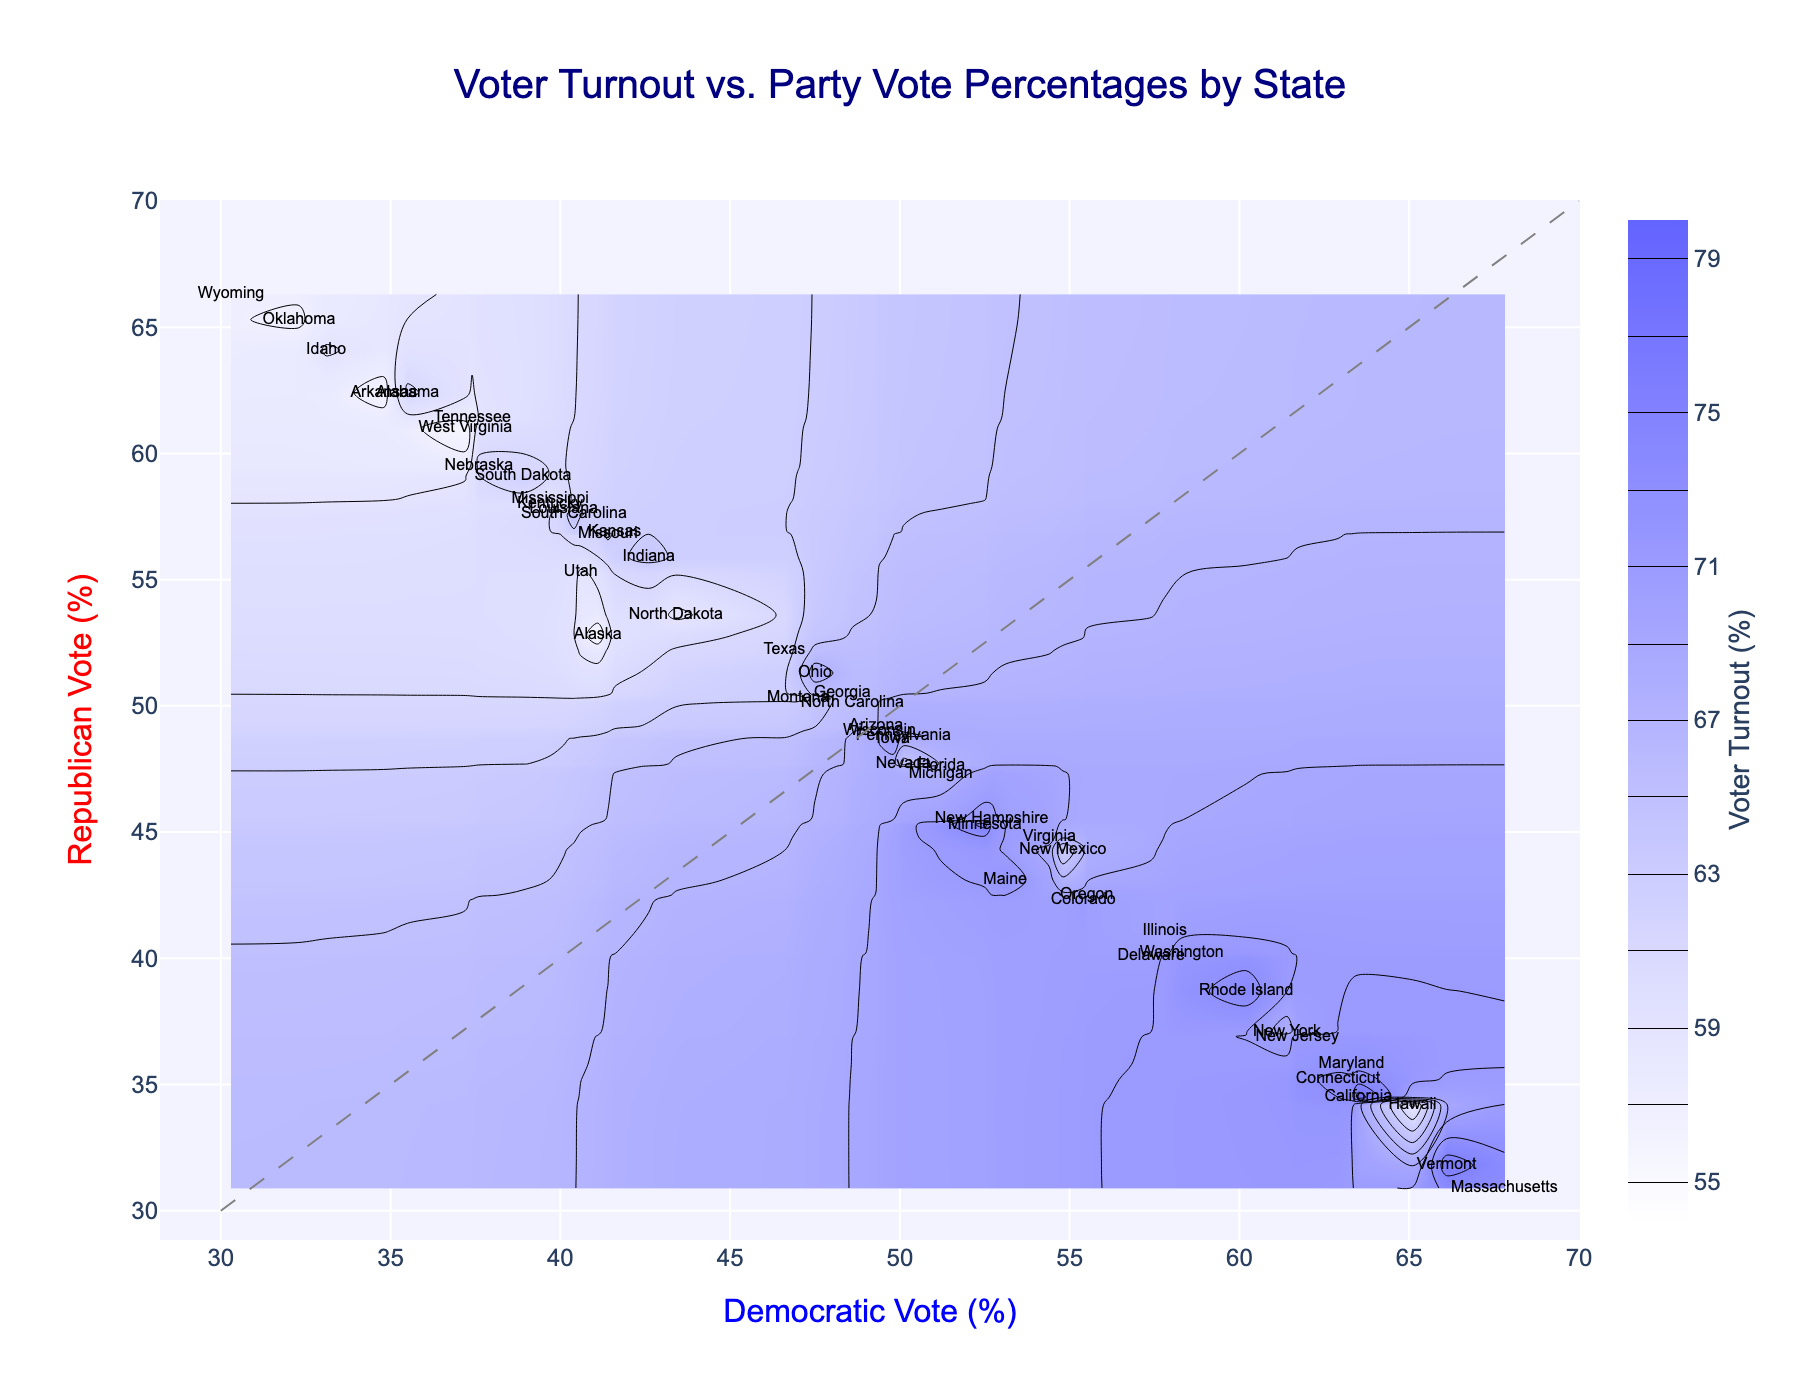What is the title of the figure? The title is typically prominently displayed at the top of the figure. In this case, the title is centered and clearly states the main focus of the visualization.
Answer: Voter Turnout vs. Party Vote Percentages by State What does the x-axis represent? The x-axis is labeled "Democratic Vote (%)", indicating that it represents the percentage of votes received by the Democratic party in each state.
Answer: Democratic Vote (%) What does the y-axis represent? The y-axis is labeled "Republican Vote (%)", indicating that it represents the percentage of votes received by the Republican party in each state.
Answer: Republican Vote (%) How is the voter turnout percentage visually represented in the plot? The voter turnout percentage is represented using a color gradient (colorscale) in the contour plot, where different shades represent different turnout percentages. The colorbar on the right side helps interpret these values.
Answer: Color gradient Which state has the highest voter turnout percentage and what is the turnout? By looking at the labels and the color scale, we identify the strongest color correlation. The state with the highest voter turnout is Vermont, marked with 76.2%.
Answer: Vermont, 76.2% Which state has a Democratic vote percentage of 66.1% and what is its Republican vote percentage? Locate the Democratic vote percentage of 66.1% on the x-axis and follow it vertically. The label for Vermont, with a Republican vote percentage of 31.8%, matches this value.
Answer: Vermont, 31.8% Which state has nearly equal Democratic and Republican vote percentages, and what are those percentages? To find the state with nearly equal percentages, look close to the diagonal line. Arizona, with 49.3% Democratic and 49.2% Republican votes, fits this criterion.
Answer: Arizona, 49.3% and 49.2% How does the voter turnout correlate with the spread between Democratic and Republican vote percentages? Examine the variation in the contour plot colors along the lines of equal voting percentages. More dispersed values generally show lower turnout, whereas more centered around one party often show higher turnout.
Answer: Higher turnout often correlates with a stronger preference for one party Which state has the lowest voter turnout and what is the Democratic and Republican vote percentages for that state? Find the state label with the lowest color scale on the plot. West Virginia has the lowest voter turnout at 55.5%, with 37.2% Democratic and 61.0% Republican votes.
Answer: West Virginia, 37.2% Democratic, 61.0% Republican 